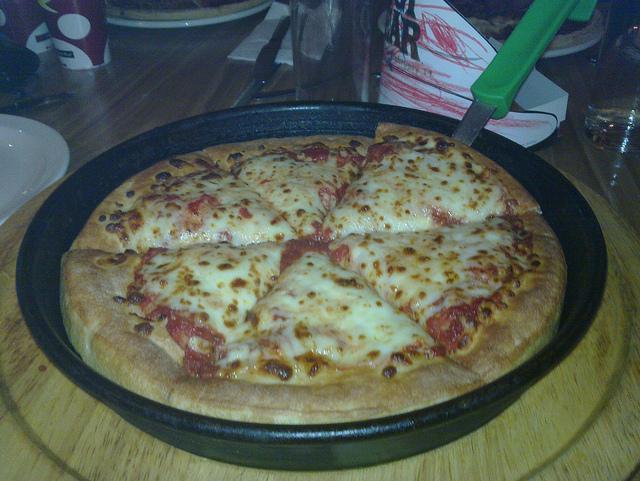How many slices of pizza are there?
Give a very brief answer. 6. How many cups are there?
Give a very brief answer. 3. 